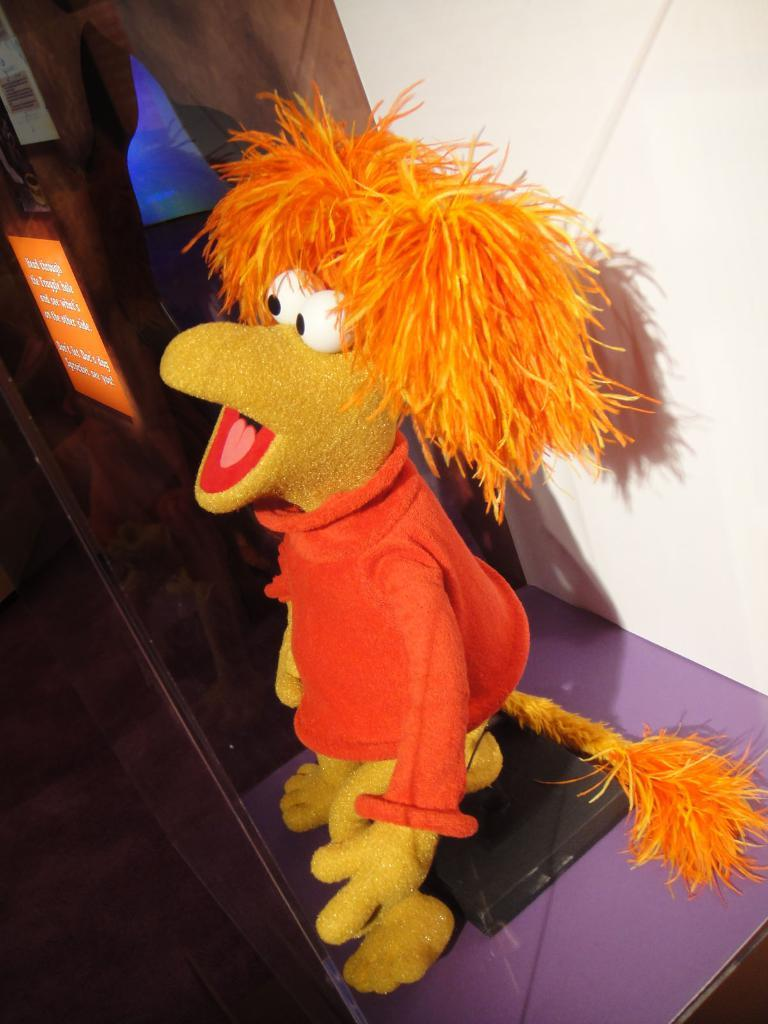What is the main subject in the center of the image? There is a toy on a stand in the center of the image. What else can be seen in the image besides the toy? There are boards in the image. What is visible in the background of the image? There is a wall in the background of the image. Can you describe the zebra wearing a mask in the image? There is no zebra or mask present in the image. 